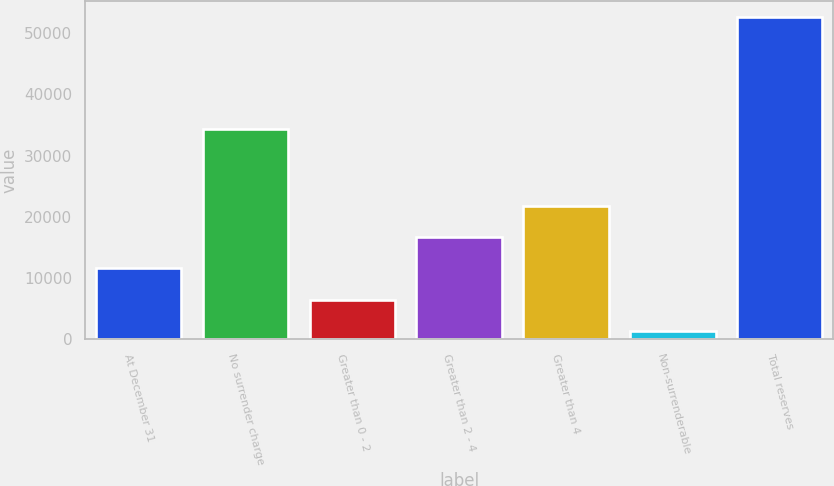Convert chart to OTSL. <chart><loc_0><loc_0><loc_500><loc_500><bar_chart><fcel>At December 31<fcel>No surrender charge<fcel>Greater than 0 - 2<fcel>Greater than 2 - 4<fcel>Greater than 4<fcel>Non-surrenderable<fcel>Total reserves<nl><fcel>11597.4<fcel>34317<fcel>6469.7<fcel>16725.1<fcel>21852.8<fcel>1342<fcel>52619<nl></chart> 